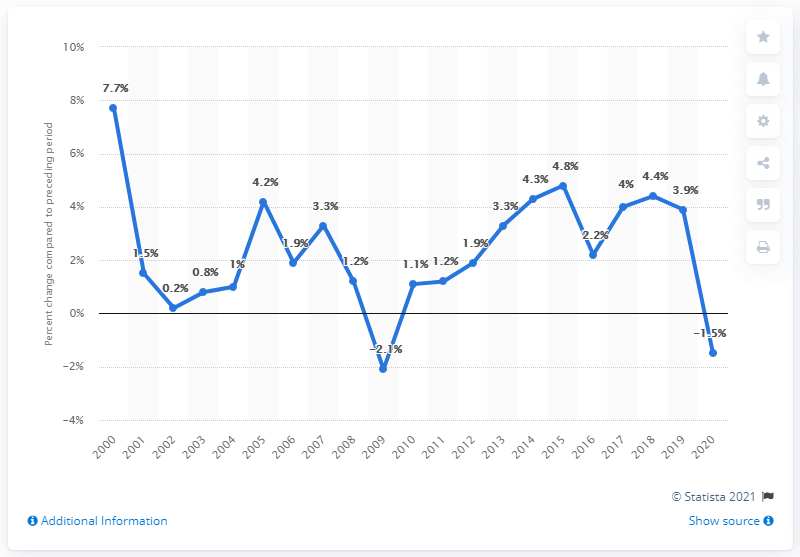Indicate a few pertinent items in this graphic. In 2000, the Gross Domestic Product (GDP) of Colorado increased by 7.7%. In 2020, Colorado's Gross Domestic Product (GDP) decreased by 1.5%. 